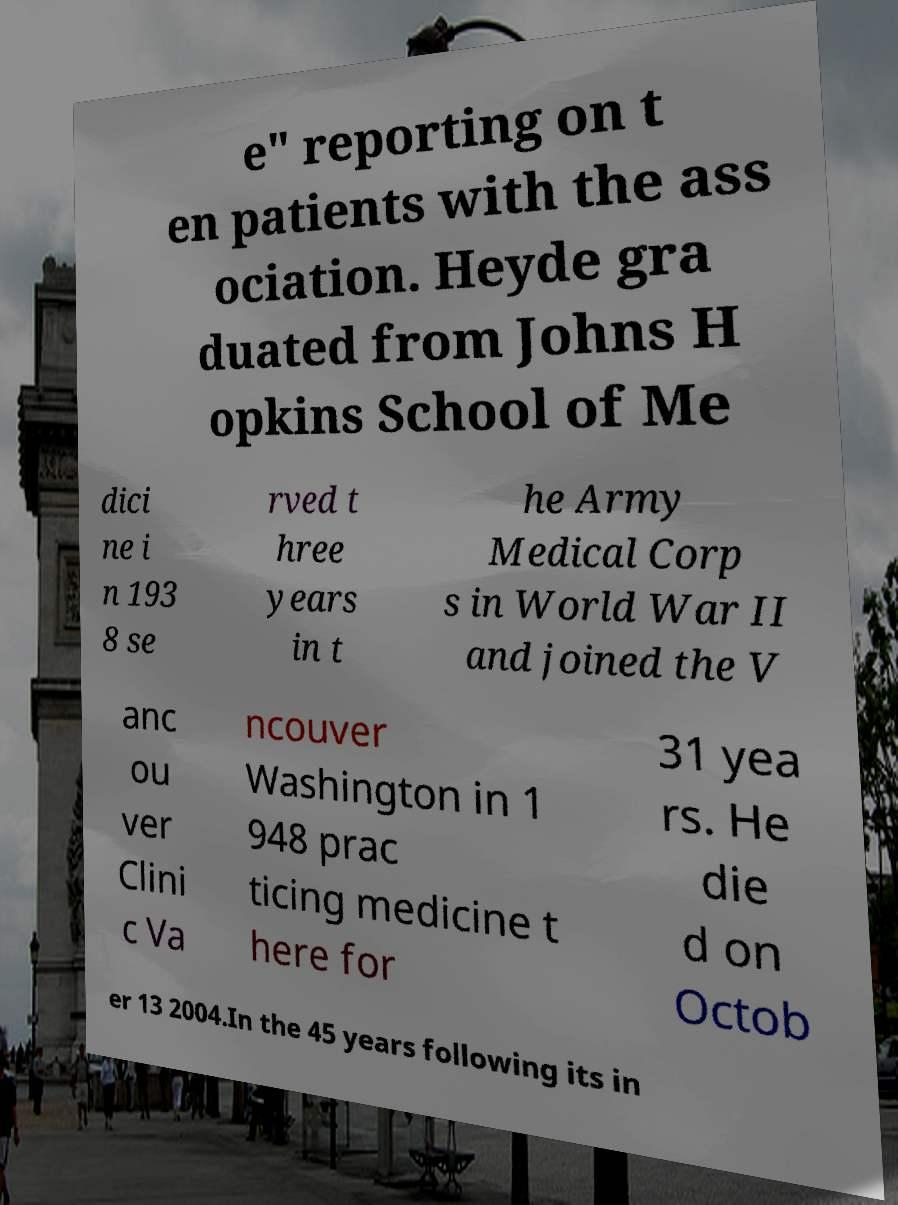What messages or text are displayed in this image? I need them in a readable, typed format. e" reporting on t en patients with the ass ociation. Heyde gra duated from Johns H opkins School of Me dici ne i n 193 8 se rved t hree years in t he Army Medical Corp s in World War II and joined the V anc ou ver Clini c Va ncouver Washington in 1 948 prac ticing medicine t here for 31 yea rs. He die d on Octob er 13 2004.In the 45 years following its in 